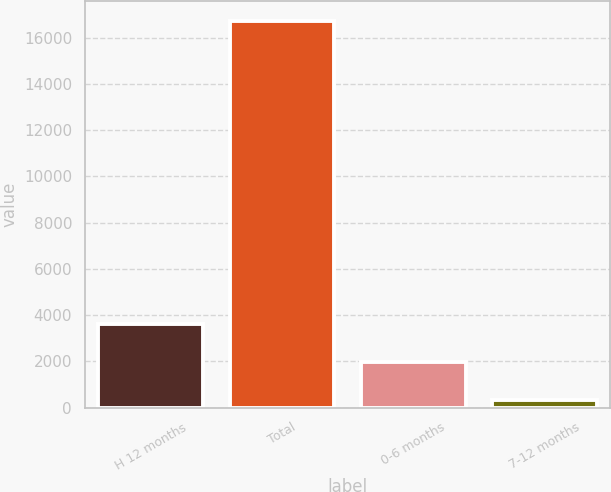Convert chart to OTSL. <chart><loc_0><loc_0><loc_500><loc_500><bar_chart><fcel>H 12 months<fcel>Total<fcel>0-6 months<fcel>7-12 months<nl><fcel>3617.4<fcel>16735<fcel>1977.7<fcel>338<nl></chart> 